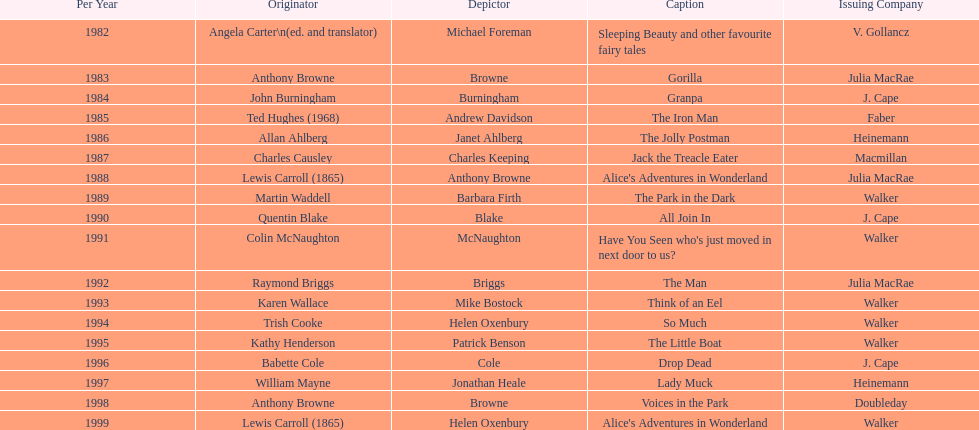How many times has anthony browne won an kurt maschler award for illustration? 3. 